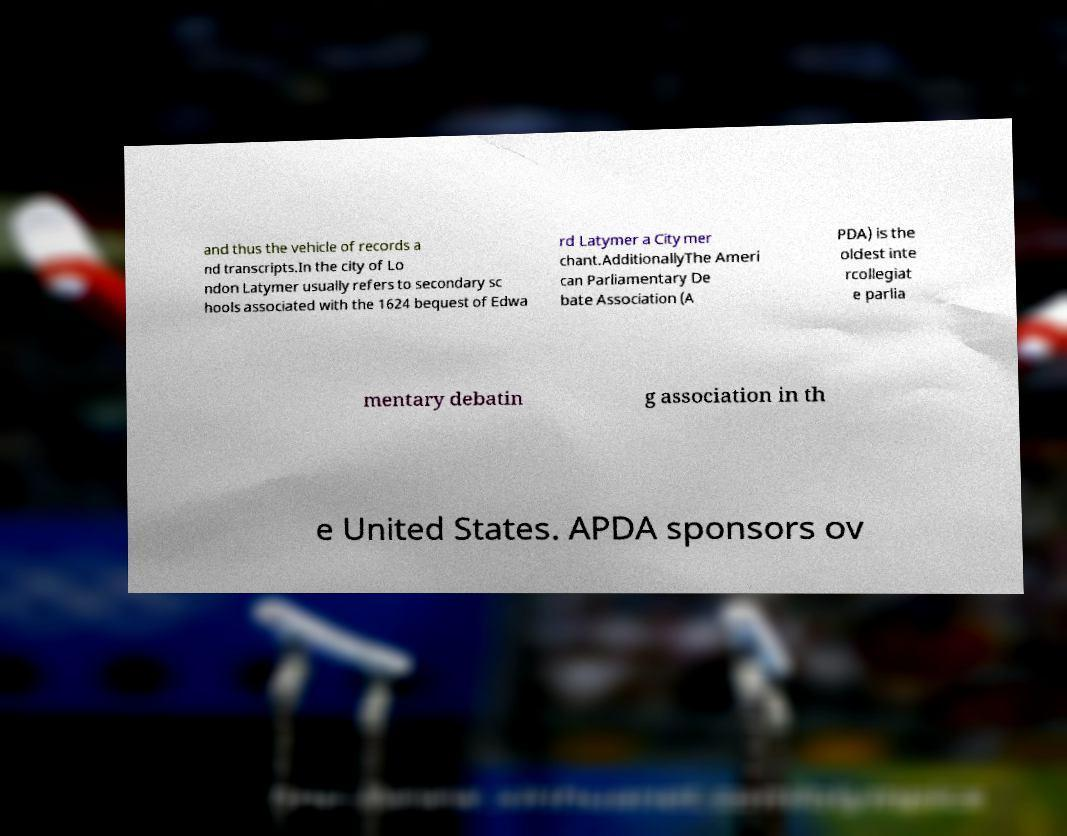Could you extract and type out the text from this image? and thus the vehicle of records a nd transcripts.In the city of Lo ndon Latymer usually refers to secondary sc hools associated with the 1624 bequest of Edwa rd Latymer a City mer chant.AdditionallyThe Ameri can Parliamentary De bate Association (A PDA) is the oldest inte rcollegiat e parlia mentary debatin g association in th e United States. APDA sponsors ov 